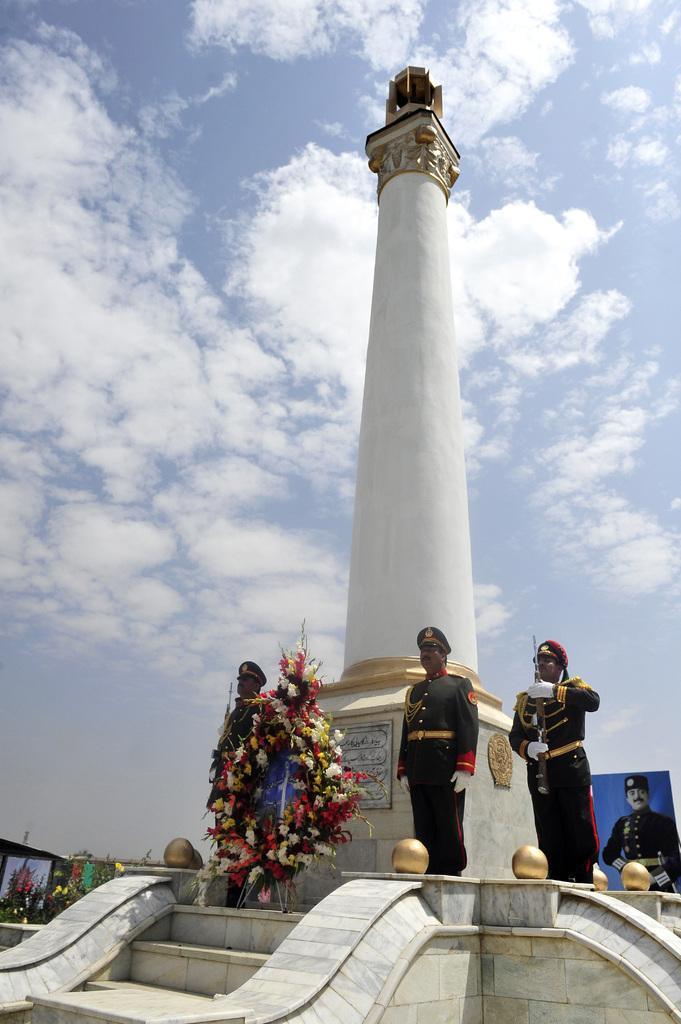Please provide a concise description of this image. In the picture we can see a pillar and on it we can see a board with some information on it and near the pillar we can see few police men are standing and near to the pillar it is decorated with flowers and near to it, we can see the steps on the four sides of the pillar and in the background we can see a sky with clouds. 